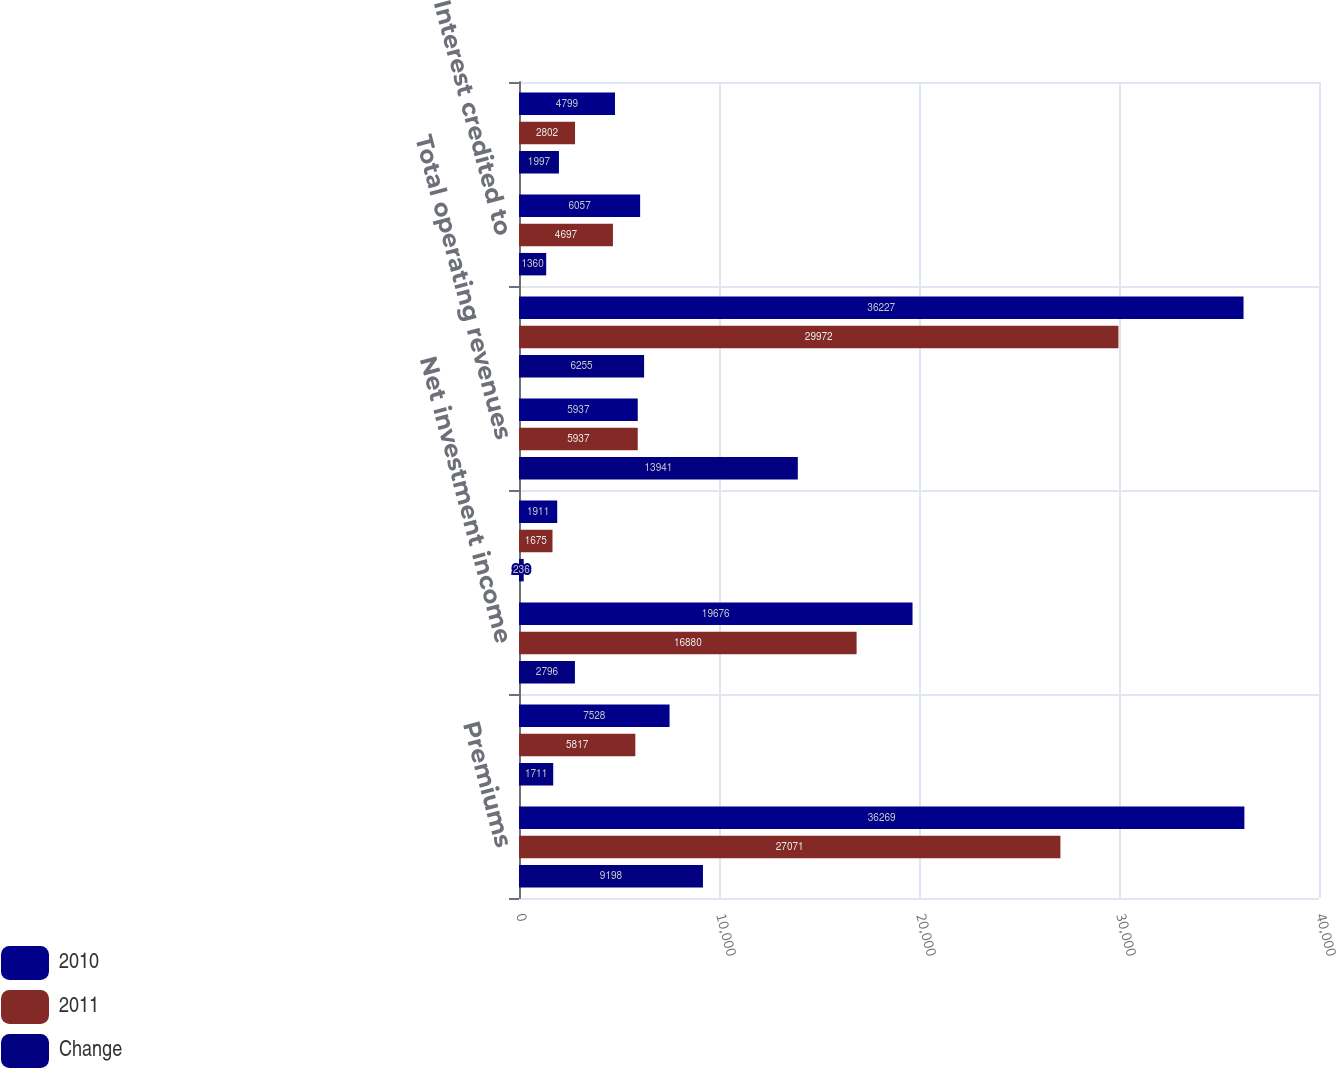Convert chart to OTSL. <chart><loc_0><loc_0><loc_500><loc_500><stacked_bar_chart><ecel><fcel>Premiums<fcel>Universal life and<fcel>Net investment income<fcel>Other revenues<fcel>Total operating revenues<fcel>Policyholder benefits and<fcel>Interest credited to<fcel>Amortization of DAC and VOBA<nl><fcel>2010<fcel>36269<fcel>7528<fcel>19676<fcel>1911<fcel>5937<fcel>36227<fcel>6057<fcel>4799<nl><fcel>2011<fcel>27071<fcel>5817<fcel>16880<fcel>1675<fcel>5937<fcel>29972<fcel>4697<fcel>2802<nl><fcel>Change<fcel>9198<fcel>1711<fcel>2796<fcel>236<fcel>13941<fcel>6255<fcel>1360<fcel>1997<nl></chart> 